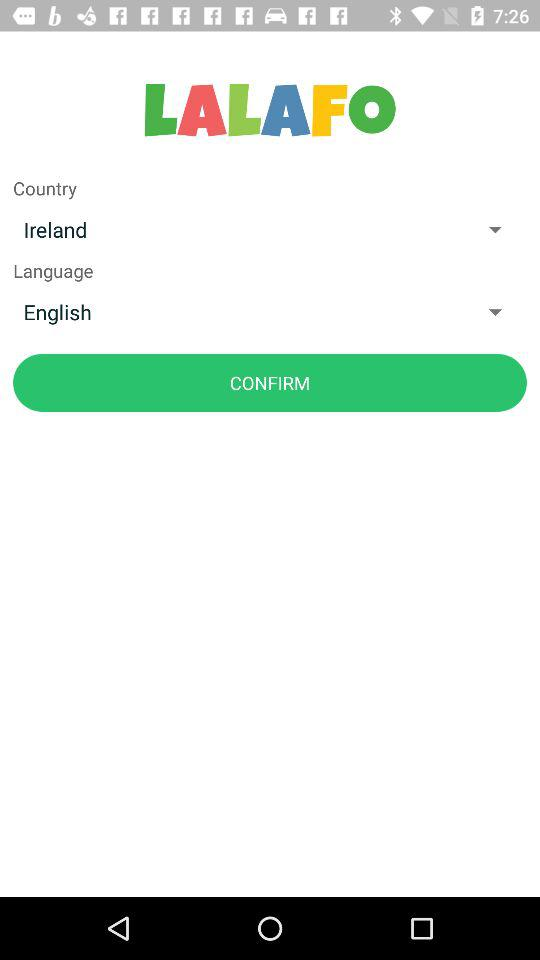Which language is selected? The selected language is English. 